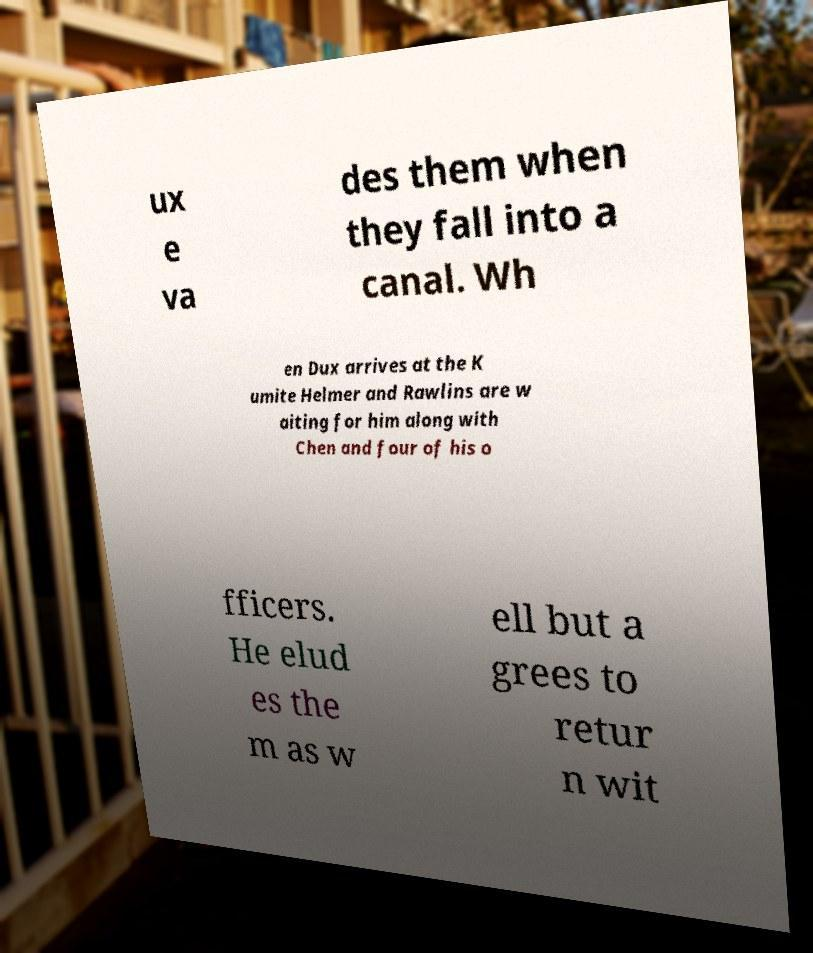Could you extract and type out the text from this image? ux e va des them when they fall into a canal. Wh en Dux arrives at the K umite Helmer and Rawlins are w aiting for him along with Chen and four of his o fficers. He elud es the m as w ell but a grees to retur n wit 